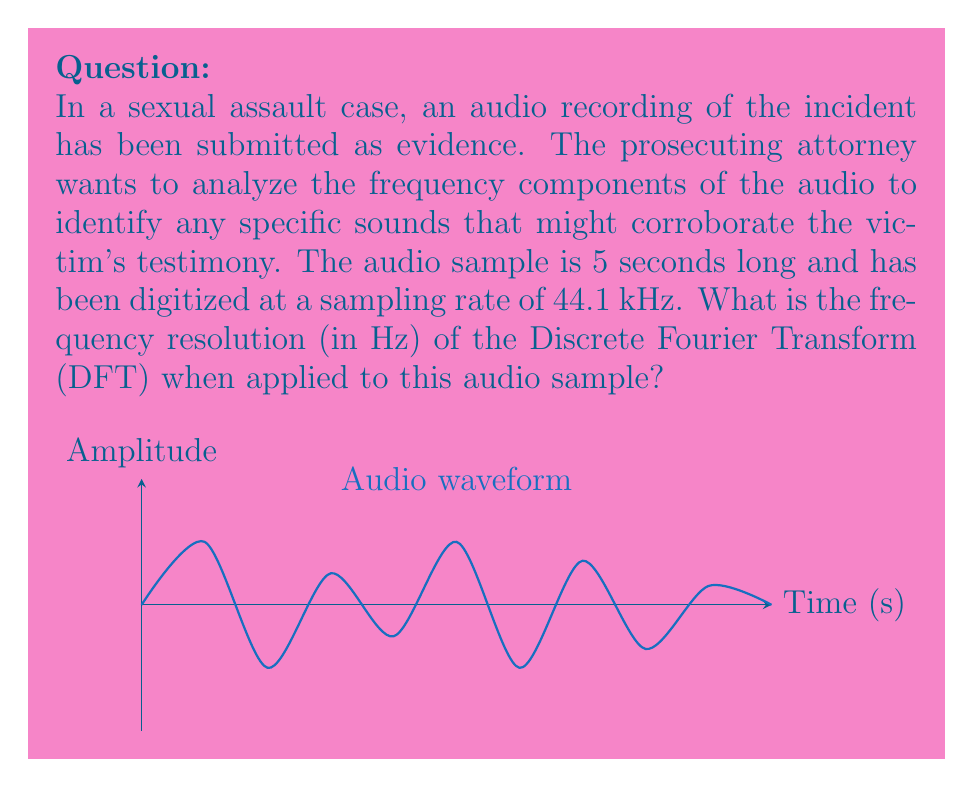Show me your answer to this math problem. To find the frequency resolution of the DFT for this audio sample, we need to follow these steps:

1) First, recall that the frequency resolution (Δf) of a DFT is given by:

   $$\Delta f = \frac{f_s}{N}$$

   where $f_s$ is the sampling frequency and $N$ is the total number of samples.

2) We are given that the sampling rate is 44.1 kHz, so:
   
   $f_s = 44100$ Hz

3) To find $N$, we need to calculate the total number of samples in the 5-second audio clip:
   
   $N = \text{sampling rate} \times \text{duration}$
   $N = 44100 \text{ Hz} \times 5 \text{ s} = 220500 \text{ samples}$

4) Now we can substitute these values into our frequency resolution formula:

   $$\Delta f = \frac{f_s}{N} = \frac{44100 \text{ Hz}}{220500} = 0.2 \text{ Hz}$$

Thus, the frequency resolution of the DFT for this audio sample is 0.2 Hz. This means that the DFT can distinguish between frequency components that are at least 0.2 Hz apart.
Answer: 0.2 Hz 